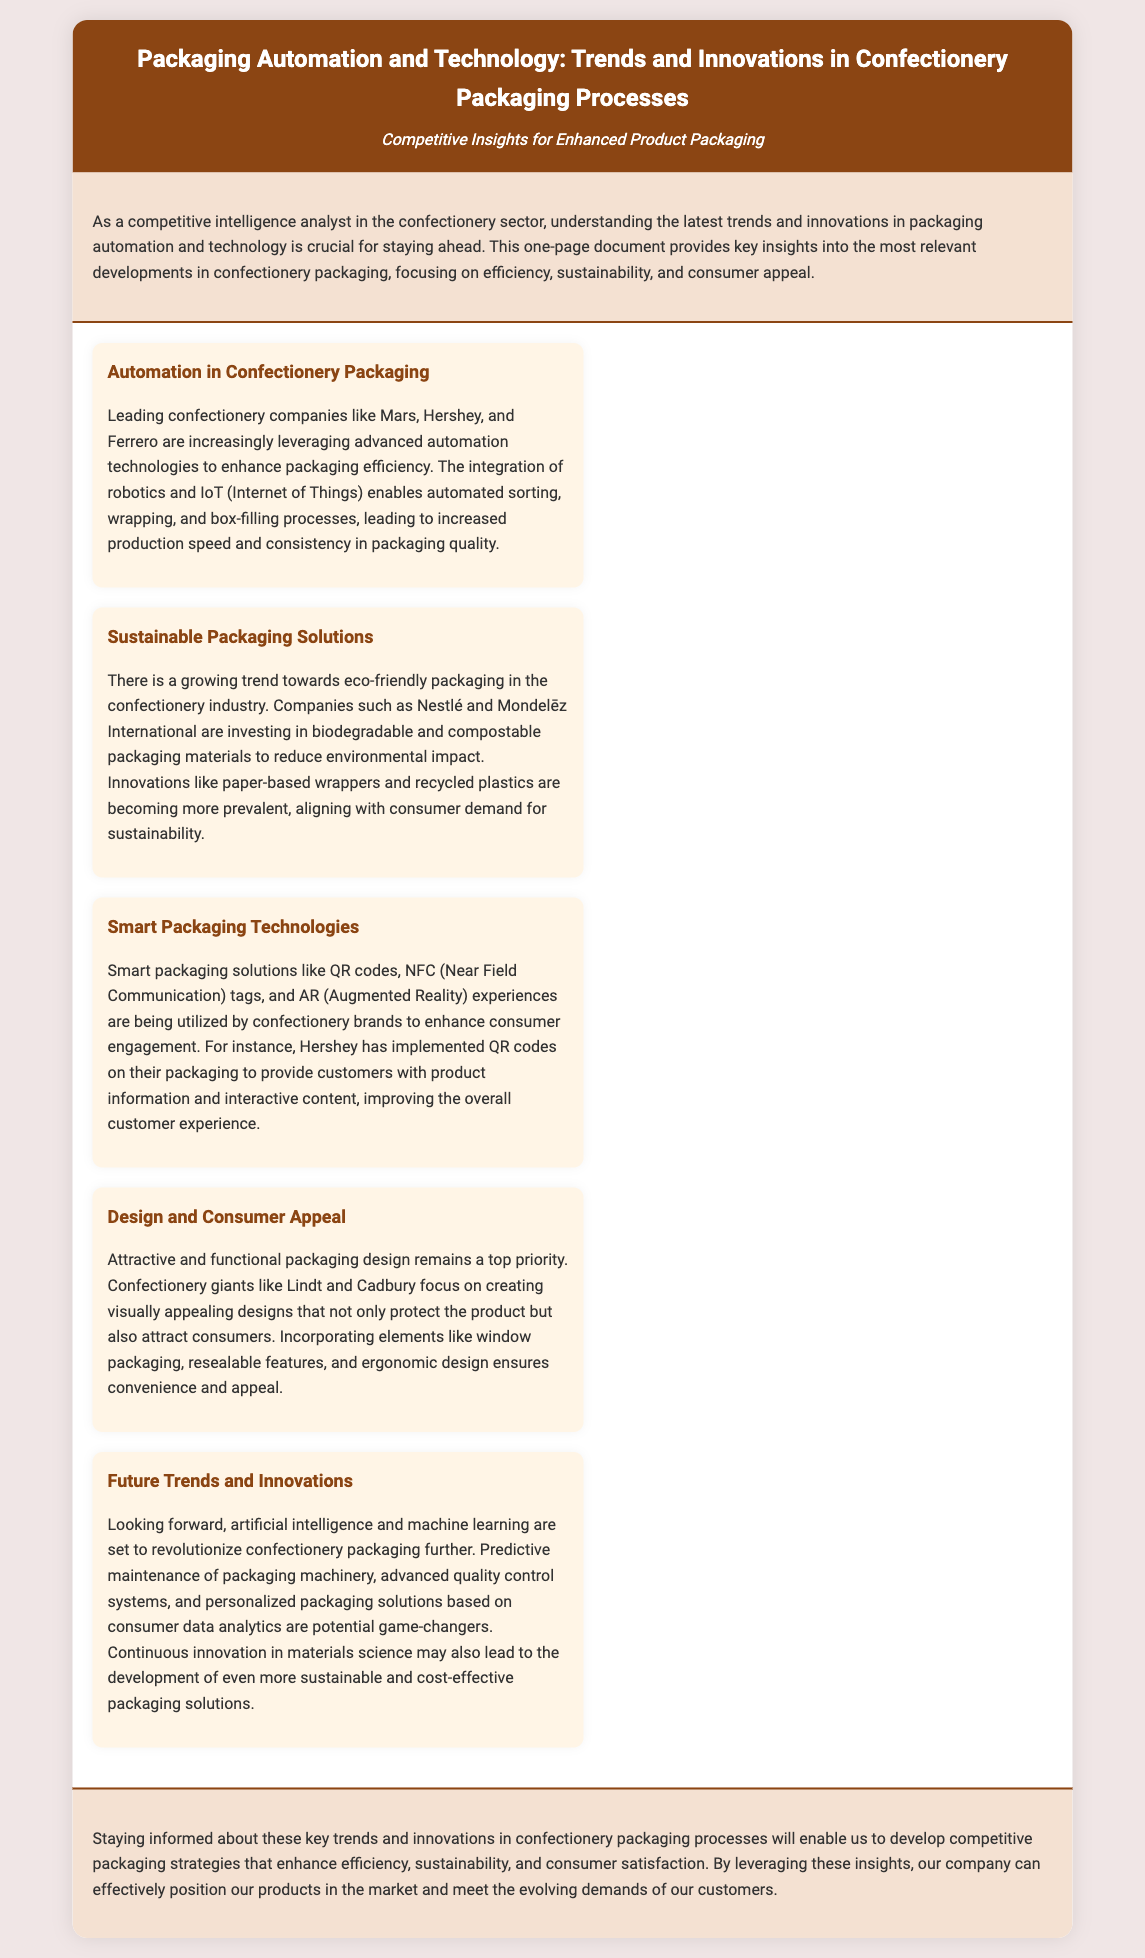What is the title of the document? The title appears at the top of the document, specifically stated as "Packaging Automation and Technology: Trends and Innovations in Confectionery Packaging Processes".
Answer: Packaging Automation and Technology: Trends and Innovations in Confectionery Packaging Processes Which companies are mentioned as leveraging automation technologies? The document lists companies such as Mars, Hershey, and Ferrero in the context of advanced automation technologies.
Answer: Mars, Hershey, Ferrero What type of packaging materials are Nestlé and Mondelēz International investing in? The document highlights that these companies are focusing on biodegradable and compostable packaging materials.
Answer: Biodegradable and compostable packaging materials What smart packaging solution is mentioned in connection with Hershey? The document specifies that Hershey has implemented QR codes on their packaging for consumer engagement.
Answer: QR codes What is a future trend in confectionery packaging according to the document? Predictive maintenance of packaging machinery is mentioned as a future trend in the document.
Answer: Predictive maintenance of packaging machinery What is the primary goal of attractive packaging design mentioned? The document states that attractive and functional packaging design aims to protect the product and attract consumers.
Answer: Protect the product and attract consumers What technology is anticipated to revolutionize packaging further? The document indicates that artificial intelligence is expected to further revolutionize packaging processes.
Answer: Artificial intelligence Which company is noted for using NFC tags? The document does not specify a particular company for NFC tags but cites the use of smart packaging technologies.
Answer: Not specified What is the main focus of the document? The main focus is on key trends and innovations in confectionery packaging processes, including efficiency and sustainability.
Answer: Key trends and innovations in confectionery packaging processes 